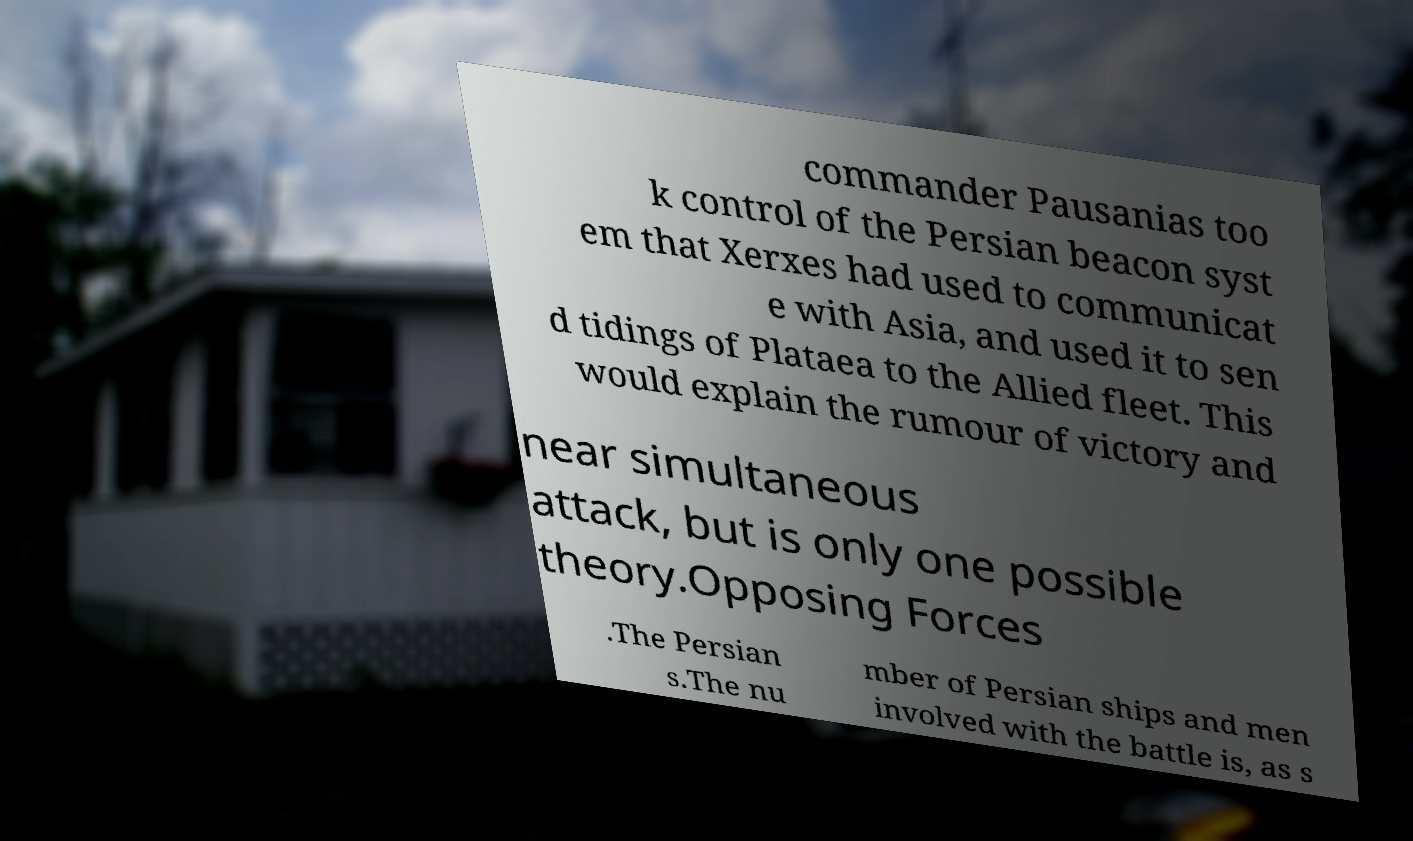Please read and relay the text visible in this image. What does it say? commander Pausanias too k control of the Persian beacon syst em that Xerxes had used to communicat e with Asia, and used it to sen d tidings of Plataea to the Allied fleet. This would explain the rumour of victory and near simultaneous attack, but is only one possible theory.Opposing Forces .The Persian s.The nu mber of Persian ships and men involved with the battle is, as s 